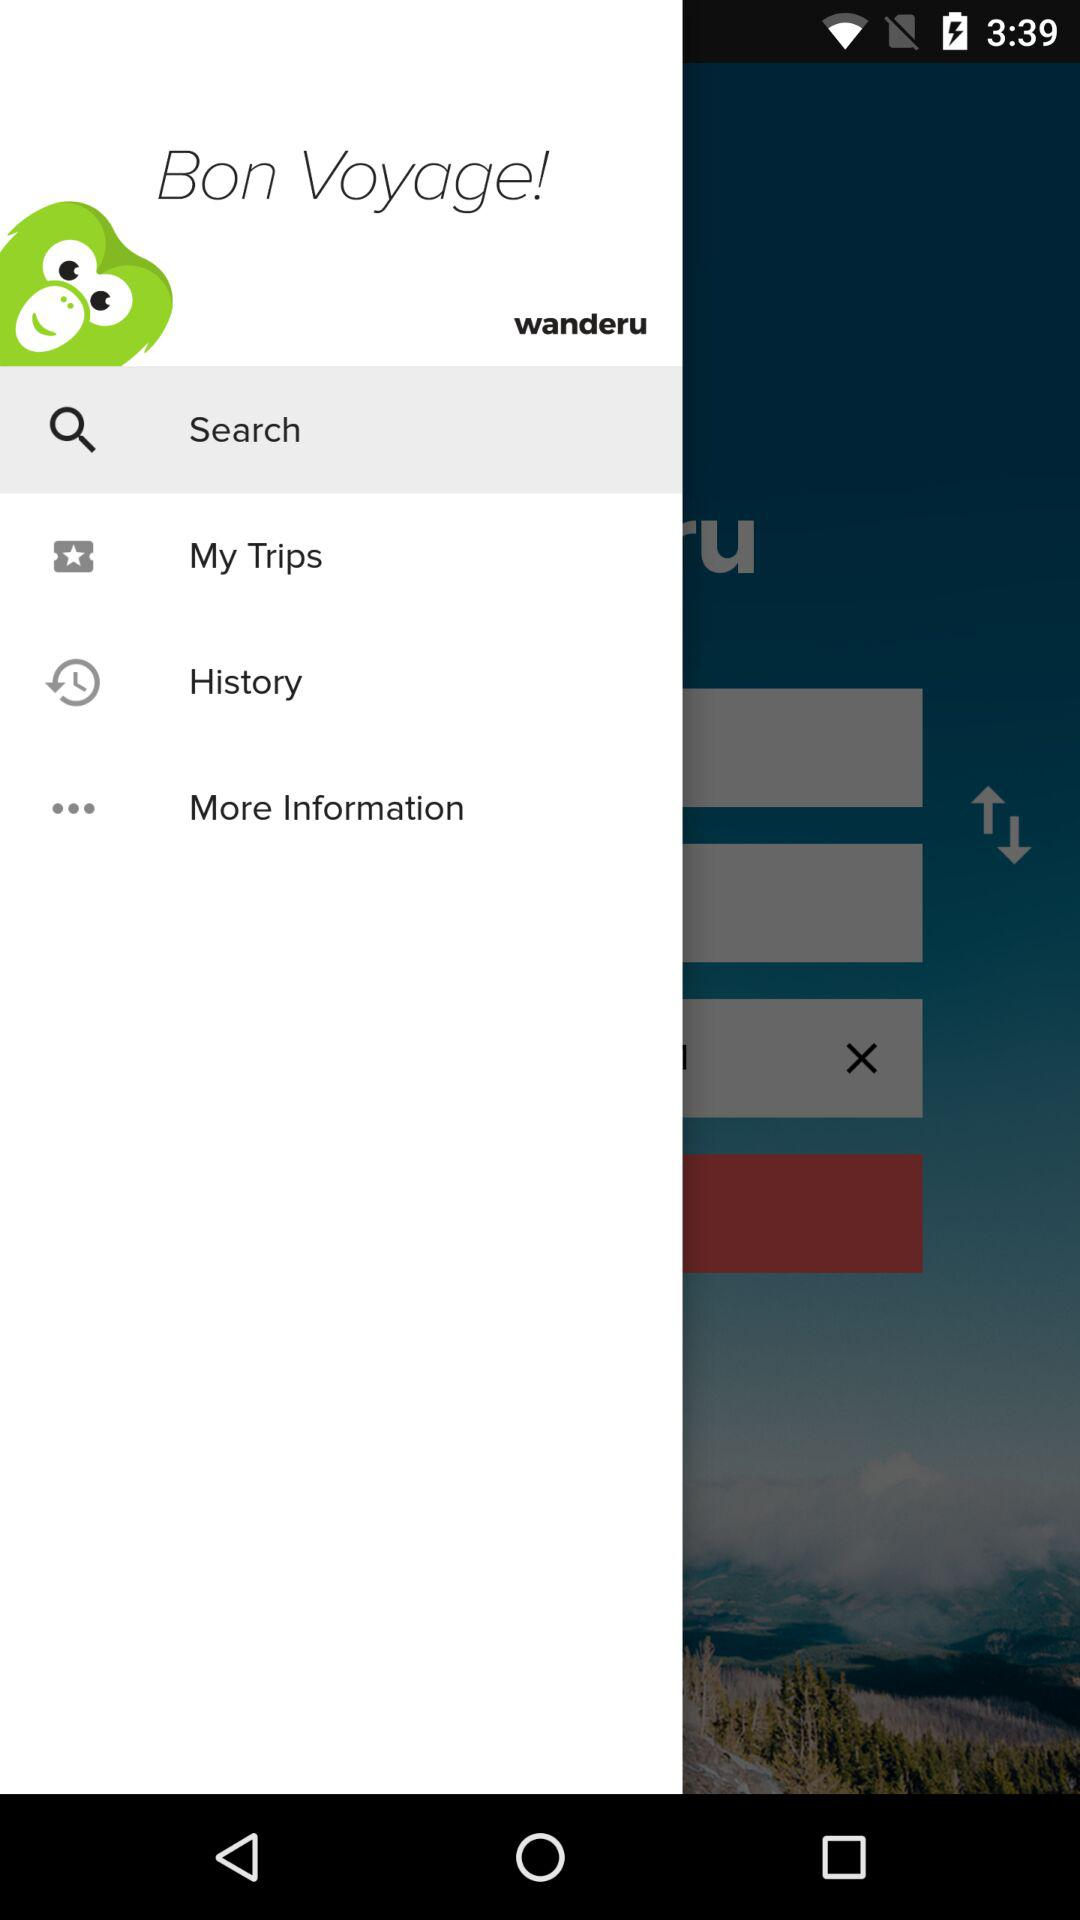What is the application name? The application name is "wanderu". 